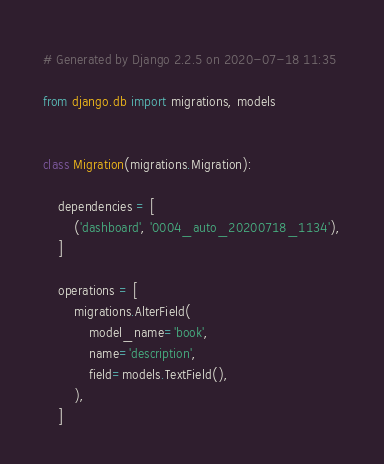Convert code to text. <code><loc_0><loc_0><loc_500><loc_500><_Python_># Generated by Django 2.2.5 on 2020-07-18 11:35

from django.db import migrations, models


class Migration(migrations.Migration):

    dependencies = [
        ('dashboard', '0004_auto_20200718_1134'),
    ]

    operations = [
        migrations.AlterField(
            model_name='book',
            name='description',
            field=models.TextField(),
        ),
    ]
</code> 